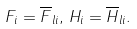<formula> <loc_0><loc_0><loc_500><loc_500>F _ { i } = \overline { F } _ { l i } , \, H _ { i } = \overline { H } _ { l i } .</formula> 